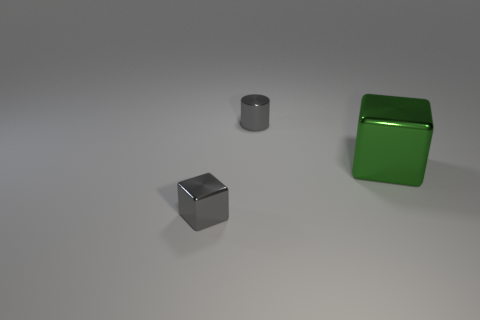Add 2 tiny cylinders. How many objects exist? 5 Subtract all cubes. How many objects are left? 1 Subtract 0 yellow cylinders. How many objects are left? 3 Subtract all metal blocks. Subtract all cylinders. How many objects are left? 0 Add 3 big green metallic blocks. How many big green metallic blocks are left? 4 Add 2 spheres. How many spheres exist? 2 